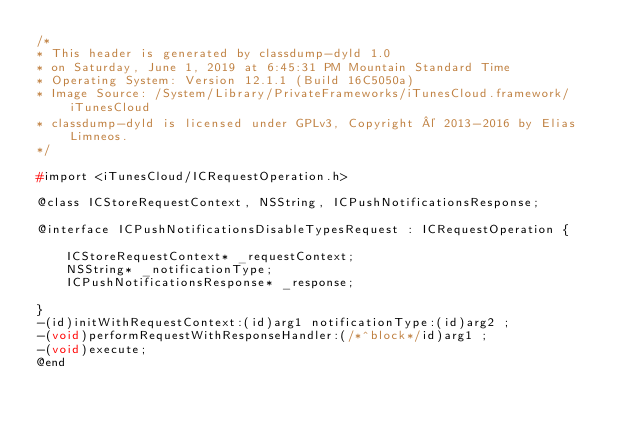<code> <loc_0><loc_0><loc_500><loc_500><_C_>/*
* This header is generated by classdump-dyld 1.0
* on Saturday, June 1, 2019 at 6:45:31 PM Mountain Standard Time
* Operating System: Version 12.1.1 (Build 16C5050a)
* Image Source: /System/Library/PrivateFrameworks/iTunesCloud.framework/iTunesCloud
* classdump-dyld is licensed under GPLv3, Copyright © 2013-2016 by Elias Limneos.
*/

#import <iTunesCloud/ICRequestOperation.h>

@class ICStoreRequestContext, NSString, ICPushNotificationsResponse;

@interface ICPushNotificationsDisableTypesRequest : ICRequestOperation {

	ICStoreRequestContext* _requestContext;
	NSString* _notificationType;
	ICPushNotificationsResponse* _response;

}
-(id)initWithRequestContext:(id)arg1 notificationType:(id)arg2 ;
-(void)performRequestWithResponseHandler:(/*^block*/id)arg1 ;
-(void)execute;
@end

</code> 